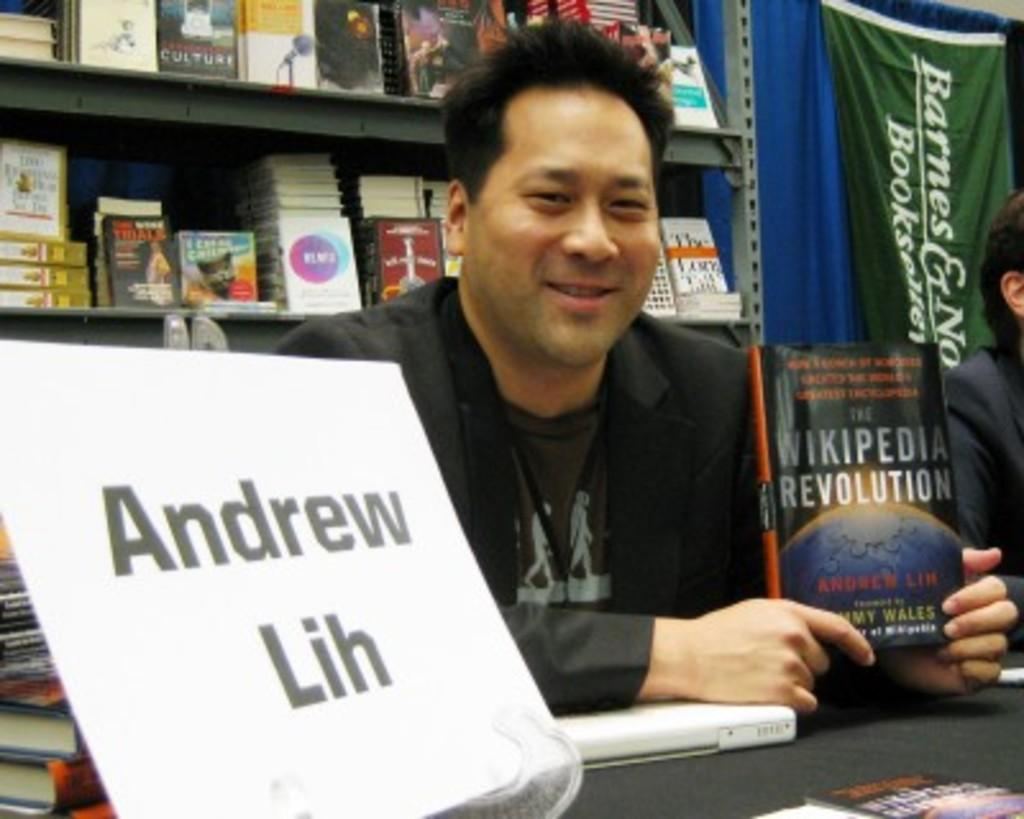<image>
Give a short and clear explanation of the subsequent image. Andrew Lih sits at a book signing holding his book the Wikipedia Revolution 